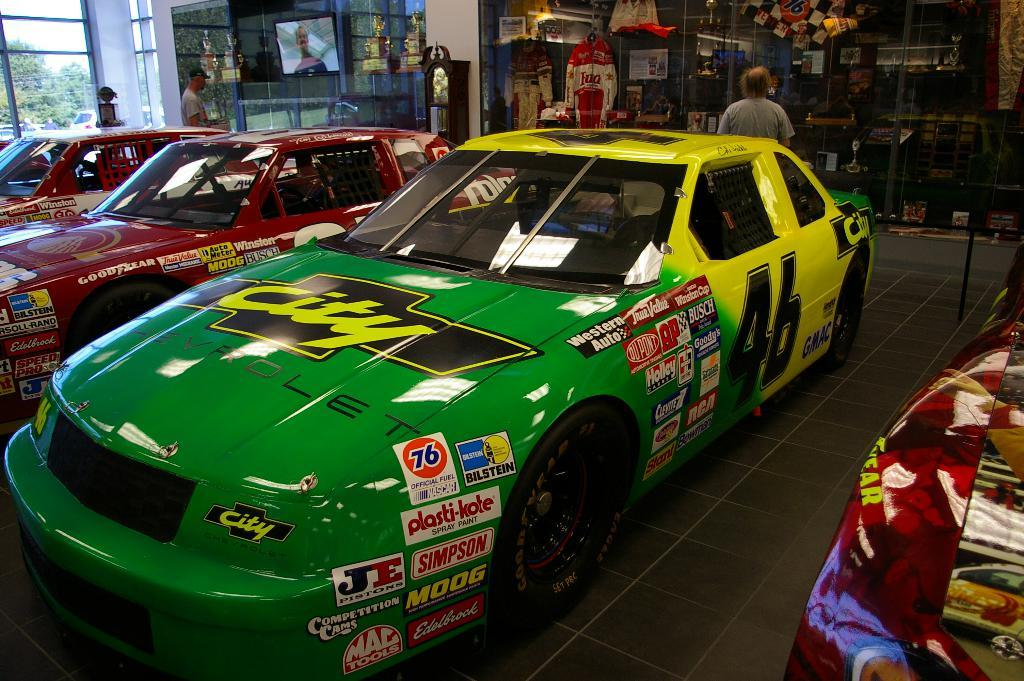<image>
Provide a brief description of the given image. Green racecar parked in doors with the word Chevrolet on the hood. 